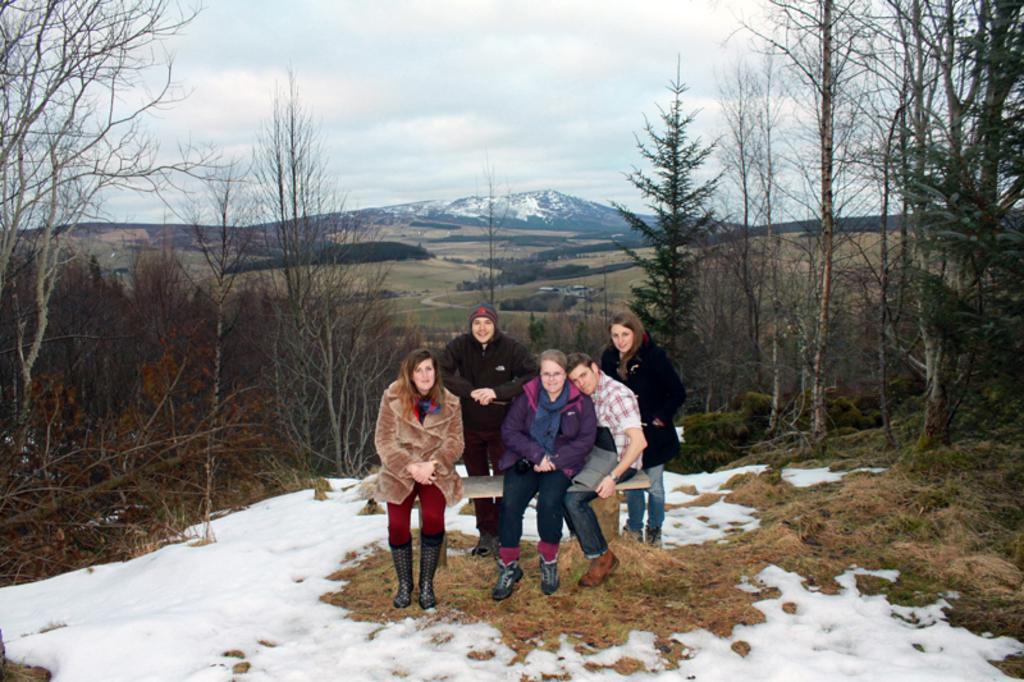How would you summarize this image in a sentence or two? In this picture I can see few people seated and couple of them standing and I can see trees and a hill and I can see snow and grass on the ground and a cloudy sky. 